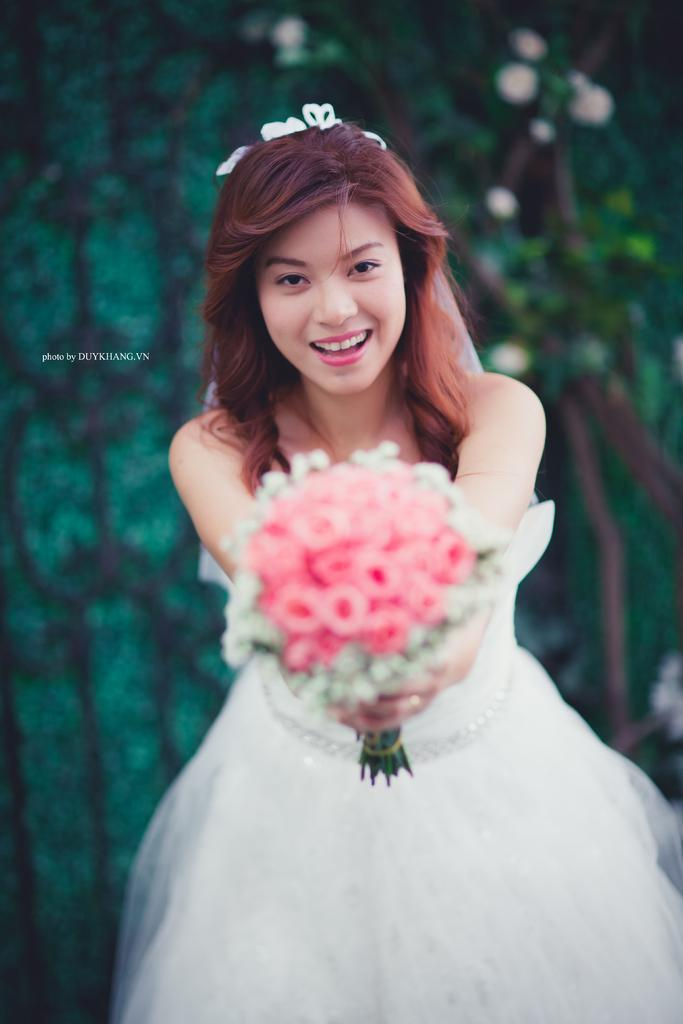Who is the main subject in the image? There is a woman in the image. What is the woman wearing? The woman is wearing a white gown. What is the woman holding in the image? The woman is holding flowers. What is the woman's facial expression? The woman is smiling. What can be seen in the background of the image? There are plants in the background of the image. What direction is the woman facing in the image? The provided facts do not mention the direction the woman is facing, so we cannot definitively answer this question. 